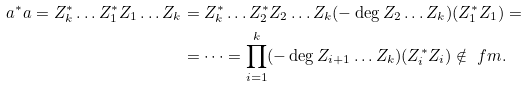Convert formula to latex. <formula><loc_0><loc_0><loc_500><loc_500>a ^ { * } a = Z _ { k } ^ { * } \dots Z _ { 1 } ^ { * } Z _ { 1 } \dots Z _ { k } & = Z _ { k } ^ { * } \dots Z _ { 2 } ^ { * } Z _ { 2 } \dots Z _ { k } ( - \deg Z _ { 2 } \dots Z _ { k } ) ( Z _ { 1 } ^ { * } Z _ { 1 } ) = \\ & = \dots = \prod _ { i = 1 } ^ { k } ( - \deg Z _ { i + 1 } \dots Z _ { k } ) ( Z _ { i } ^ { * } Z _ { i } ) \notin \ f m .</formula> 